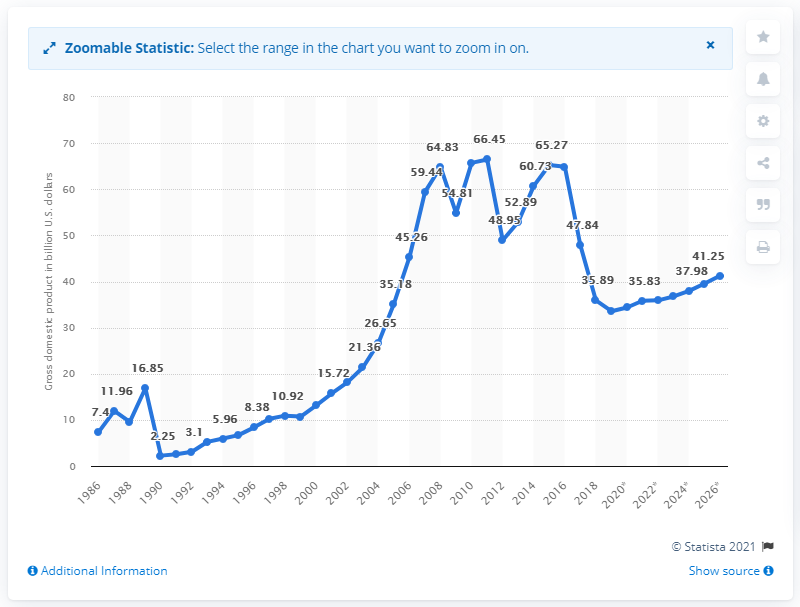Outline some significant characteristics in this image. In 2019, the gross domestic product of Sudan was 33.56. 